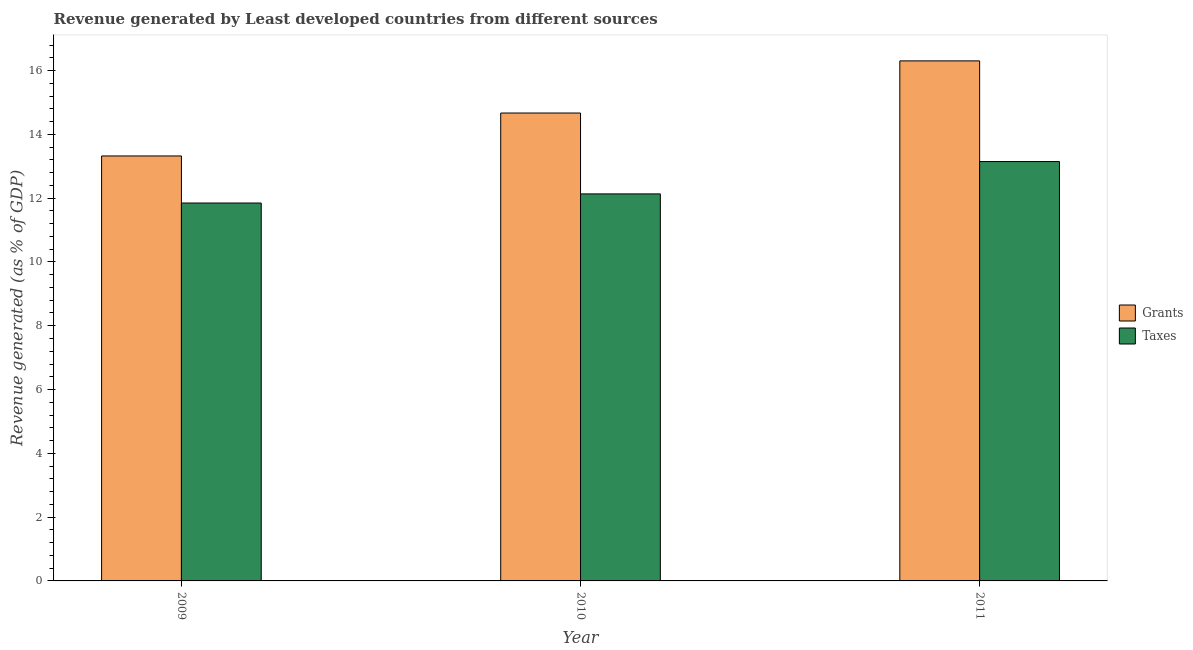Are the number of bars per tick equal to the number of legend labels?
Provide a short and direct response. Yes. Are the number of bars on each tick of the X-axis equal?
Offer a very short reply. Yes. How many bars are there on the 3rd tick from the left?
Offer a terse response. 2. How many bars are there on the 1st tick from the right?
Offer a very short reply. 2. What is the revenue generated by taxes in 2009?
Ensure brevity in your answer.  11.85. Across all years, what is the maximum revenue generated by grants?
Offer a very short reply. 16.3. Across all years, what is the minimum revenue generated by grants?
Make the answer very short. 13.32. In which year was the revenue generated by grants maximum?
Keep it short and to the point. 2011. What is the total revenue generated by taxes in the graph?
Make the answer very short. 37.13. What is the difference between the revenue generated by grants in 2009 and that in 2011?
Give a very brief answer. -2.98. What is the difference between the revenue generated by taxes in 2011 and the revenue generated by grants in 2010?
Offer a very short reply. 1.01. What is the average revenue generated by taxes per year?
Offer a terse response. 12.38. In the year 2011, what is the difference between the revenue generated by taxes and revenue generated by grants?
Your answer should be compact. 0. What is the ratio of the revenue generated by grants in 2010 to that in 2011?
Your response must be concise. 0.9. Is the revenue generated by grants in 2009 less than that in 2011?
Your response must be concise. Yes. What is the difference between the highest and the second highest revenue generated by grants?
Give a very brief answer. 1.64. What is the difference between the highest and the lowest revenue generated by taxes?
Provide a succinct answer. 1.3. In how many years, is the revenue generated by taxes greater than the average revenue generated by taxes taken over all years?
Your response must be concise. 1. Is the sum of the revenue generated by grants in 2009 and 2011 greater than the maximum revenue generated by taxes across all years?
Give a very brief answer. Yes. What does the 1st bar from the left in 2011 represents?
Keep it short and to the point. Grants. What does the 2nd bar from the right in 2010 represents?
Your answer should be very brief. Grants. Are all the bars in the graph horizontal?
Your answer should be compact. No. How many years are there in the graph?
Your response must be concise. 3. What is the difference between two consecutive major ticks on the Y-axis?
Provide a short and direct response. 2. Are the values on the major ticks of Y-axis written in scientific E-notation?
Provide a succinct answer. No. Does the graph contain any zero values?
Offer a very short reply. No. How are the legend labels stacked?
Provide a short and direct response. Vertical. What is the title of the graph?
Keep it short and to the point. Revenue generated by Least developed countries from different sources. What is the label or title of the Y-axis?
Give a very brief answer. Revenue generated (as % of GDP). What is the Revenue generated (as % of GDP) in Grants in 2009?
Your answer should be compact. 13.32. What is the Revenue generated (as % of GDP) in Taxes in 2009?
Provide a short and direct response. 11.85. What is the Revenue generated (as % of GDP) in Grants in 2010?
Make the answer very short. 14.67. What is the Revenue generated (as % of GDP) in Taxes in 2010?
Give a very brief answer. 12.13. What is the Revenue generated (as % of GDP) in Grants in 2011?
Keep it short and to the point. 16.3. What is the Revenue generated (as % of GDP) in Taxes in 2011?
Your answer should be compact. 13.15. Across all years, what is the maximum Revenue generated (as % of GDP) in Grants?
Provide a short and direct response. 16.3. Across all years, what is the maximum Revenue generated (as % of GDP) of Taxes?
Offer a terse response. 13.15. Across all years, what is the minimum Revenue generated (as % of GDP) in Grants?
Your response must be concise. 13.32. Across all years, what is the minimum Revenue generated (as % of GDP) in Taxes?
Your response must be concise. 11.85. What is the total Revenue generated (as % of GDP) of Grants in the graph?
Your response must be concise. 44.3. What is the total Revenue generated (as % of GDP) in Taxes in the graph?
Provide a short and direct response. 37.13. What is the difference between the Revenue generated (as % of GDP) in Grants in 2009 and that in 2010?
Your answer should be compact. -1.35. What is the difference between the Revenue generated (as % of GDP) in Taxes in 2009 and that in 2010?
Your response must be concise. -0.29. What is the difference between the Revenue generated (as % of GDP) of Grants in 2009 and that in 2011?
Make the answer very short. -2.98. What is the difference between the Revenue generated (as % of GDP) of Taxes in 2009 and that in 2011?
Offer a terse response. -1.3. What is the difference between the Revenue generated (as % of GDP) in Grants in 2010 and that in 2011?
Your response must be concise. -1.64. What is the difference between the Revenue generated (as % of GDP) in Taxes in 2010 and that in 2011?
Your response must be concise. -1.01. What is the difference between the Revenue generated (as % of GDP) of Grants in 2009 and the Revenue generated (as % of GDP) of Taxes in 2010?
Give a very brief answer. 1.19. What is the difference between the Revenue generated (as % of GDP) of Grants in 2009 and the Revenue generated (as % of GDP) of Taxes in 2011?
Offer a very short reply. 0.18. What is the difference between the Revenue generated (as % of GDP) of Grants in 2010 and the Revenue generated (as % of GDP) of Taxes in 2011?
Your answer should be compact. 1.52. What is the average Revenue generated (as % of GDP) of Grants per year?
Provide a short and direct response. 14.77. What is the average Revenue generated (as % of GDP) in Taxes per year?
Your answer should be very brief. 12.38. In the year 2009, what is the difference between the Revenue generated (as % of GDP) in Grants and Revenue generated (as % of GDP) in Taxes?
Give a very brief answer. 1.48. In the year 2010, what is the difference between the Revenue generated (as % of GDP) of Grants and Revenue generated (as % of GDP) of Taxes?
Give a very brief answer. 2.54. In the year 2011, what is the difference between the Revenue generated (as % of GDP) of Grants and Revenue generated (as % of GDP) of Taxes?
Keep it short and to the point. 3.16. What is the ratio of the Revenue generated (as % of GDP) in Grants in 2009 to that in 2010?
Ensure brevity in your answer.  0.91. What is the ratio of the Revenue generated (as % of GDP) in Taxes in 2009 to that in 2010?
Offer a very short reply. 0.98. What is the ratio of the Revenue generated (as % of GDP) of Grants in 2009 to that in 2011?
Provide a succinct answer. 0.82. What is the ratio of the Revenue generated (as % of GDP) in Taxes in 2009 to that in 2011?
Your answer should be compact. 0.9. What is the ratio of the Revenue generated (as % of GDP) in Grants in 2010 to that in 2011?
Make the answer very short. 0.9. What is the ratio of the Revenue generated (as % of GDP) in Taxes in 2010 to that in 2011?
Your response must be concise. 0.92. What is the difference between the highest and the second highest Revenue generated (as % of GDP) in Grants?
Offer a very short reply. 1.64. What is the difference between the highest and the lowest Revenue generated (as % of GDP) in Grants?
Provide a short and direct response. 2.98. What is the difference between the highest and the lowest Revenue generated (as % of GDP) in Taxes?
Your response must be concise. 1.3. 